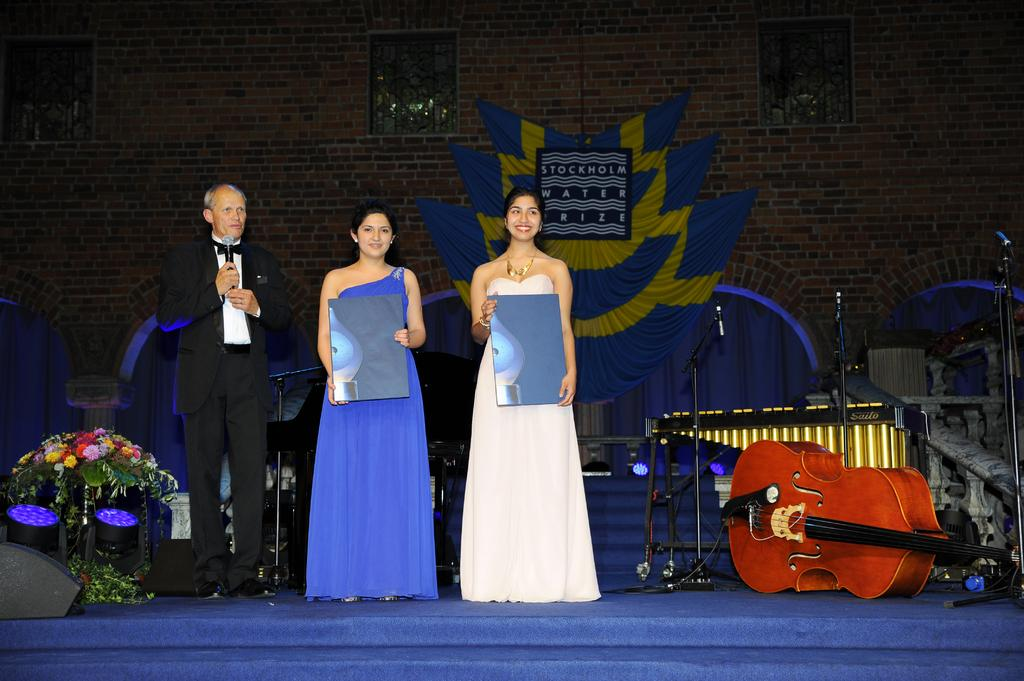How many people are in the image? There are three persons standing in the image. What is one person holding in the image? One person is holding a microphone. What musical instrument can be seen in the image? There is a guitar in the image. How many microphones are visible in the image? There are microphones with stands in the image. What other musical instrument is present in the image? There is a piano in the image. What can be seen in the background of the image? There is a wall and a banner in the background of the image. What type of lace is draped over the piano in the image? There is no lace draped over the piano in the image; it is a musical instrument with no decorative elements mentioned. 